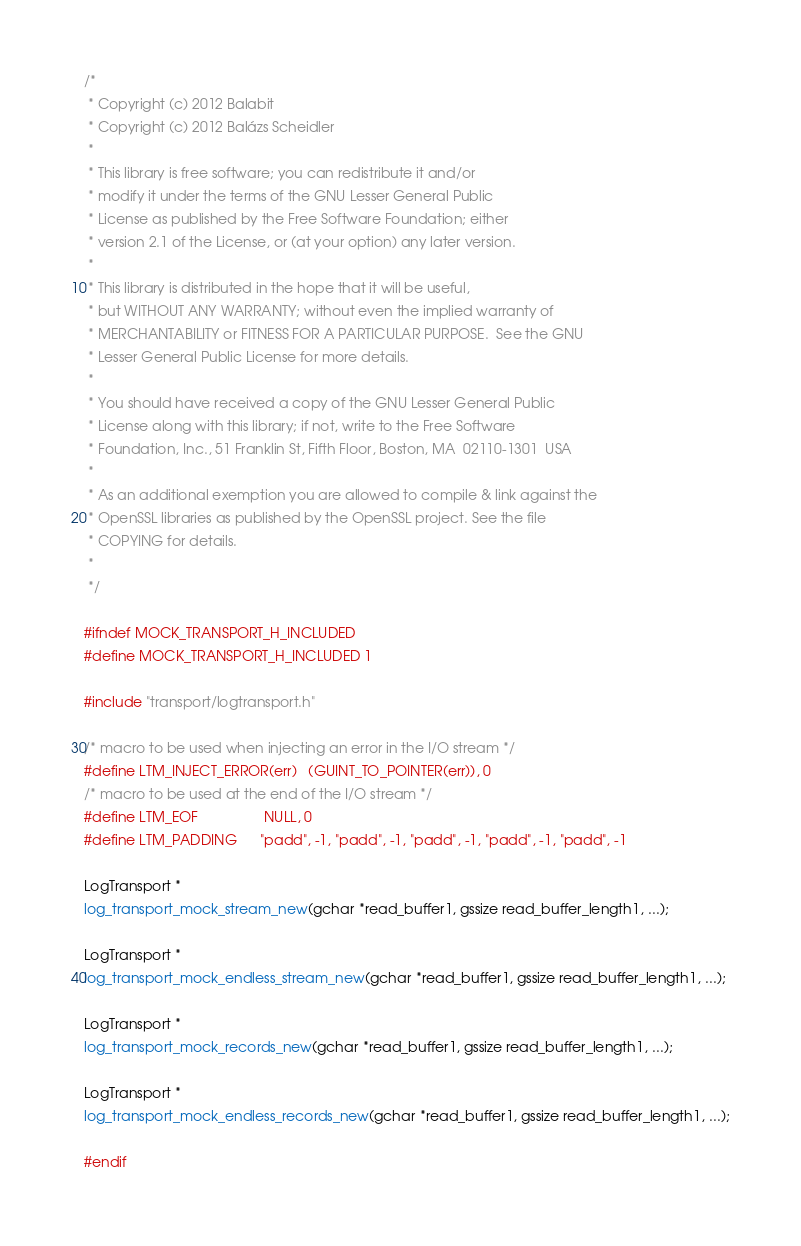Convert code to text. <code><loc_0><loc_0><loc_500><loc_500><_C_>/*
 * Copyright (c) 2012 Balabit
 * Copyright (c) 2012 Balázs Scheidler
 *
 * This library is free software; you can redistribute it and/or
 * modify it under the terms of the GNU Lesser General Public
 * License as published by the Free Software Foundation; either
 * version 2.1 of the License, or (at your option) any later version.
 *
 * This library is distributed in the hope that it will be useful,
 * but WITHOUT ANY WARRANTY; without even the implied warranty of
 * MERCHANTABILITY or FITNESS FOR A PARTICULAR PURPOSE.  See the GNU
 * Lesser General Public License for more details.
 *
 * You should have received a copy of the GNU Lesser General Public
 * License along with this library; if not, write to the Free Software
 * Foundation, Inc., 51 Franklin St, Fifth Floor, Boston, MA  02110-1301  USA
 *
 * As an additional exemption you are allowed to compile & link against the
 * OpenSSL libraries as published by the OpenSSL project. See the file
 * COPYING for details.
 *
 */

#ifndef MOCK_TRANSPORT_H_INCLUDED
#define MOCK_TRANSPORT_H_INCLUDED 1

#include "transport/logtransport.h"

/* macro to be used when injecting an error in the I/O stream */
#define LTM_INJECT_ERROR(err)   (GUINT_TO_POINTER(err)), 0
/* macro to be used at the end of the I/O stream */
#define LTM_EOF                 NULL, 0
#define LTM_PADDING		"padd", -1, "padd", -1, "padd", -1, "padd", -1, "padd", -1

LogTransport *
log_transport_mock_stream_new(gchar *read_buffer1, gssize read_buffer_length1, ...);

LogTransport *
log_transport_mock_endless_stream_new(gchar *read_buffer1, gssize read_buffer_length1, ...);

LogTransport *
log_transport_mock_records_new(gchar *read_buffer1, gssize read_buffer_length1, ...);

LogTransport *
log_transport_mock_endless_records_new(gchar *read_buffer1, gssize read_buffer_length1, ...);

#endif
</code> 